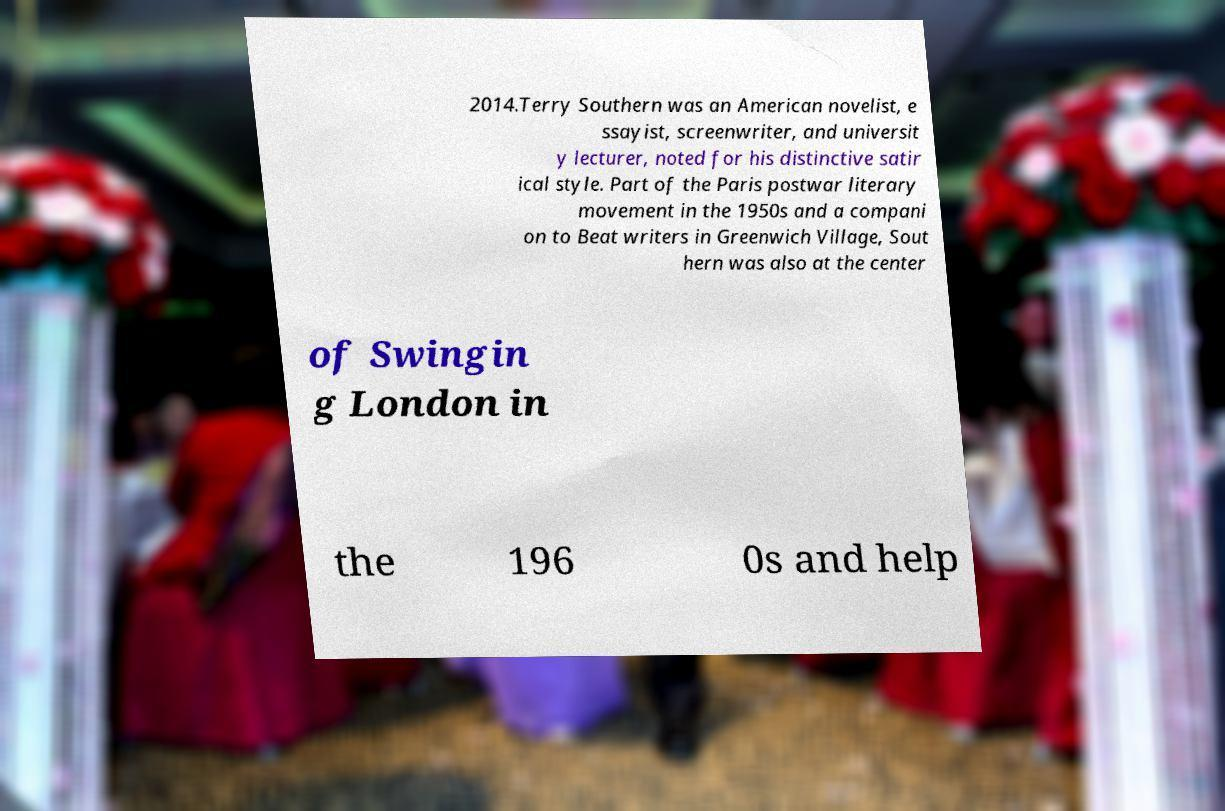Please identify and transcribe the text found in this image. 2014.Terry Southern was an American novelist, e ssayist, screenwriter, and universit y lecturer, noted for his distinctive satir ical style. Part of the Paris postwar literary movement in the 1950s and a compani on to Beat writers in Greenwich Village, Sout hern was also at the center of Swingin g London in the 196 0s and help 